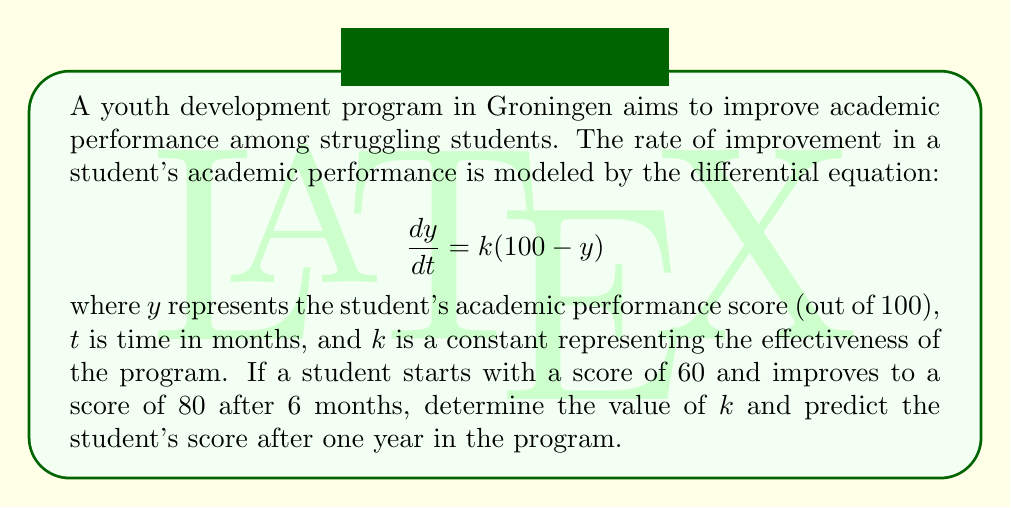Show me your answer to this math problem. To solve this problem, we'll follow these steps:

1. Solve the differential equation:
The given equation is a first-order linear differential equation.
$$\frac{dy}{dt} = k(100 - y)$$
This can be rewritten as:
$$\frac{dy}{100 - y} = k dt$$
Integrating both sides:
$$-\ln|100 - y| = kt + C$$
Solving for $y$:
$$y = 100 - Ae^{-kt}$$
where $A$ is a constant of integration.

2. Use the initial condition to find $A$:
At $t = 0$, $y = 60$
$$60 = 100 - A$$
$$A = 40$$

So, the general solution is:
$$y = 100 - 40e^{-kt}$$

3. Use the given information to find $k$:
After 6 months ($t = 6$), $y = 80$
$$80 = 100 - 40e^{-6k}$$
$$20 = 40e^{-6k}$$
$$\frac{1}{2} = e^{-6k}$$
$$\ln(\frac{1}{2}) = -6k$$
$$k = \frac{\ln(2)}{6} \approx 0.1155$$

4. Predict the score after one year:
Using $t = 12$ (months) and $k = 0.1155$:
$$y = 100 - 40e^{-0.1155 \cdot 12}$$
$$y = 100 - 40e^{-1.386}$$
$$y \approx 90.0$$
Answer: The value of $k$ is approximately 0.1155, and the student's predicted score after one year in the program is approximately 90.0. 